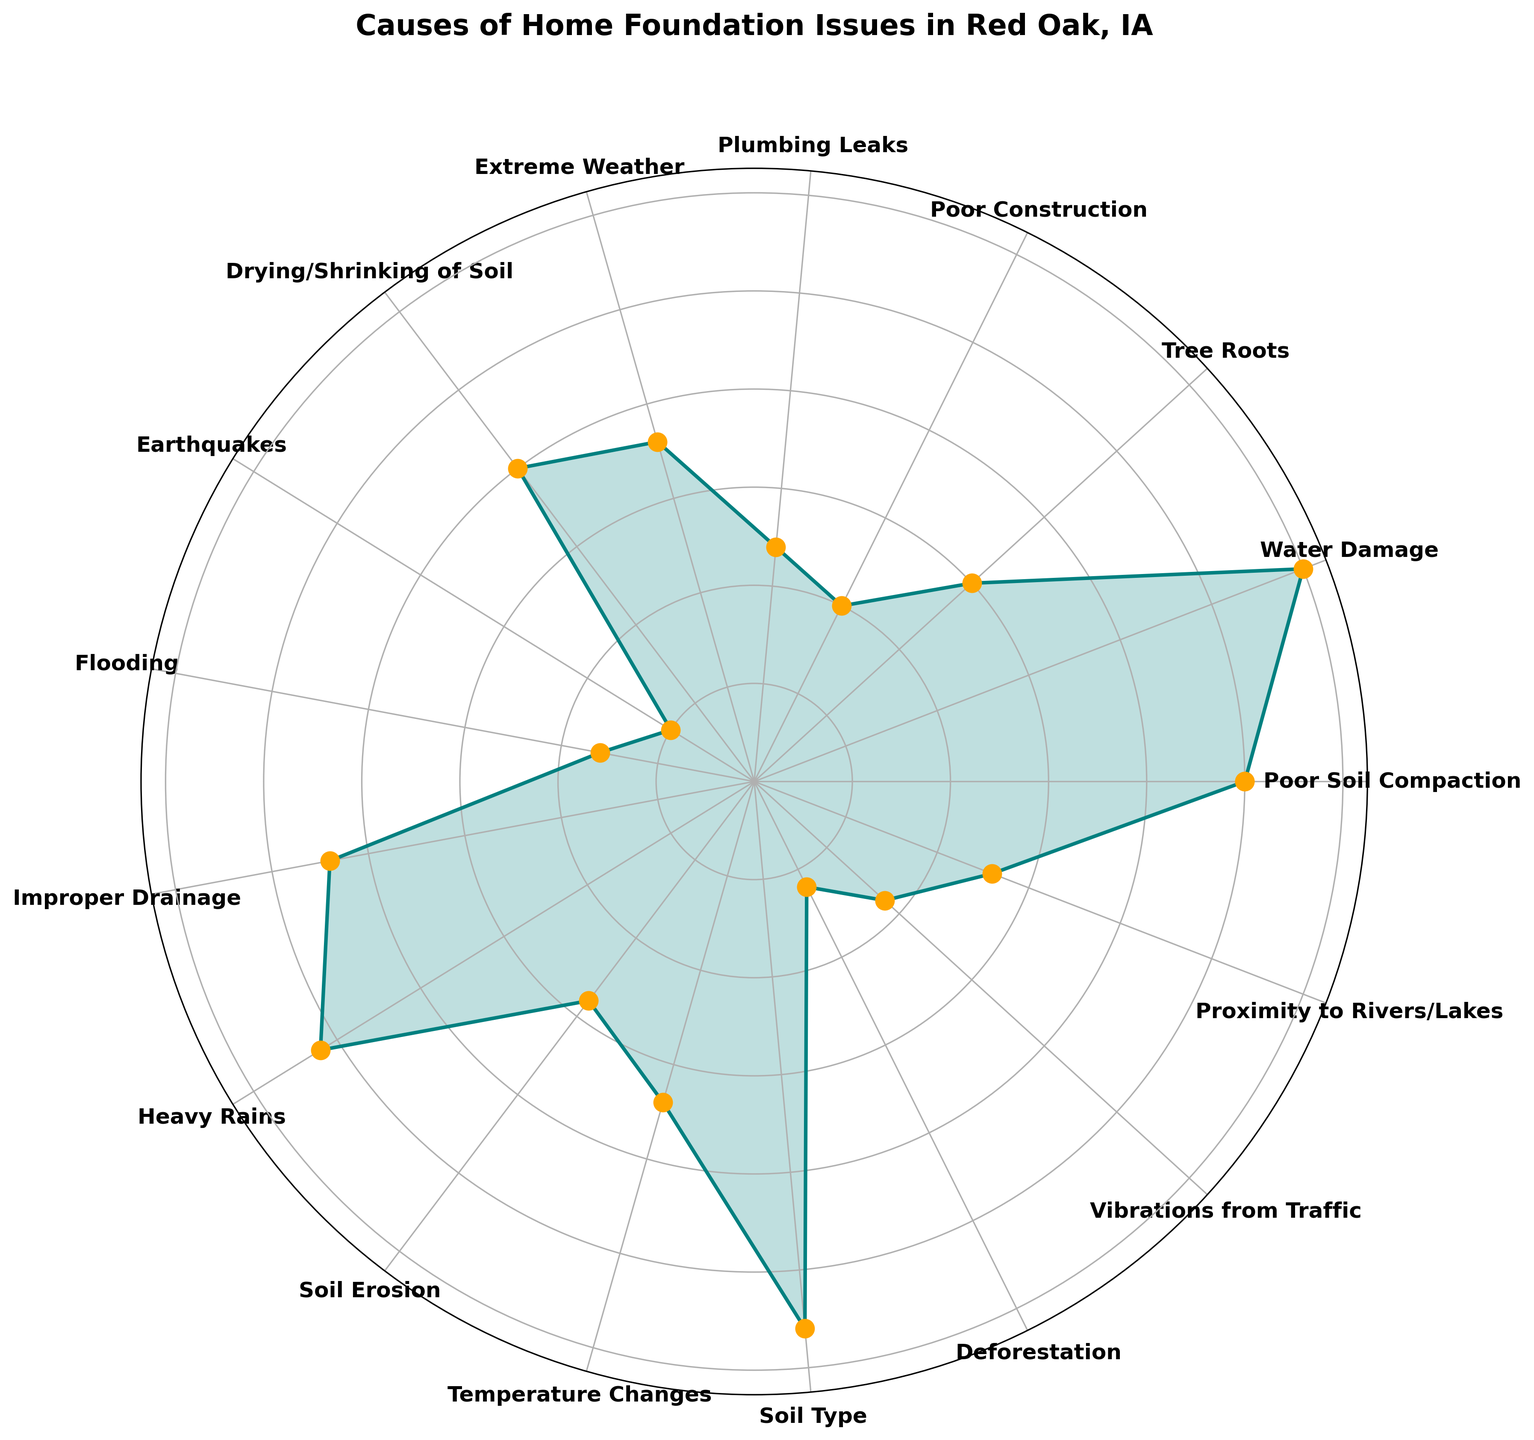Which cause of home foundation issues is the most frequent? The chart shows different categories with varying lengths representing their frequencies. The longest section corresponds to "Water Damage".
Answer: Water Damage Which cause has a frequency most similar to Tree Roots? Tree Roots has a slightly shorter bar compared to some of the other categories. The one closest to it in length is "Soil Erosion".
Answer: Soil Erosion What is the total frequency for Water Damage, Poor Soil Compaction, and Heavy Rains combined? The frequencies for these causes are 30, 25, and 26, respectively. Adding them together: 30 + 25 + 26 = 81.
Answer: 81 How many causes have a frequency greater than 20 but less than 25? By examining the lengths of the chart sections, "Poor Soil Compaction" with a frequency of 25 fits in this range.
Answer: 1 Which cause has the lowest frequency and what is it? The shortest section in the chart represents "Earthquakes", indicating that it has the lowest frequency.
Answer: Earthquakes, 5 What is the average frequency of issues related to soil, such as Poor Soil Compaction, Drying/Shrinking of Soil, Soil Erosion, and Soil Type? The frequencies are 25, 20, 14, and 28, respectively. Adding them: 25 + 20 + 14 + 28 = 87. Dividing by 4: 87 / 4 = 21.75.
Answer: 21.75 Compare the frequency of Plumbing Leaks to Improper Drainage. Which is higher and by how much? Plumbing Leaks has a frequency of 12, and Improper Drainage has a frequency of 22. The difference: 22 - 12 = 10.
Answer: Improper Drainage, by 10 Identify the causes with frequencies between 10 and 15. The frequencies within this range are "Plumbing Leaks" (12) and "Soil Erosion" (14).
Answer: Plumbing Leaks, Soil Erosion What is the frequency difference between the most and least common causes? The highest frequency is Water Damage (30) and the lowest is Earthquakes (5). The difference: 30 - 5 = 25.
Answer: 25 